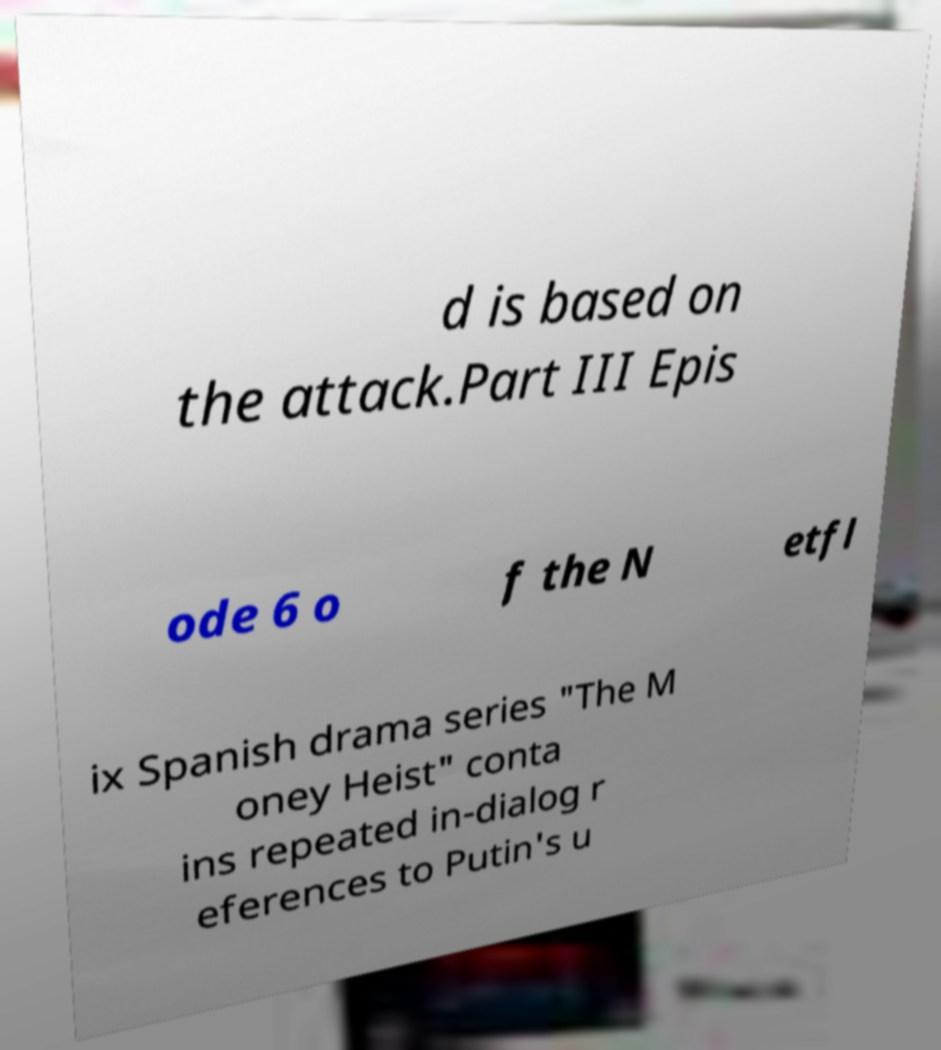I need the written content from this picture converted into text. Can you do that? d is based on the attack.Part III Epis ode 6 o f the N etfl ix Spanish drama series "The M oney Heist" conta ins repeated in-dialog r eferences to Putin's u 